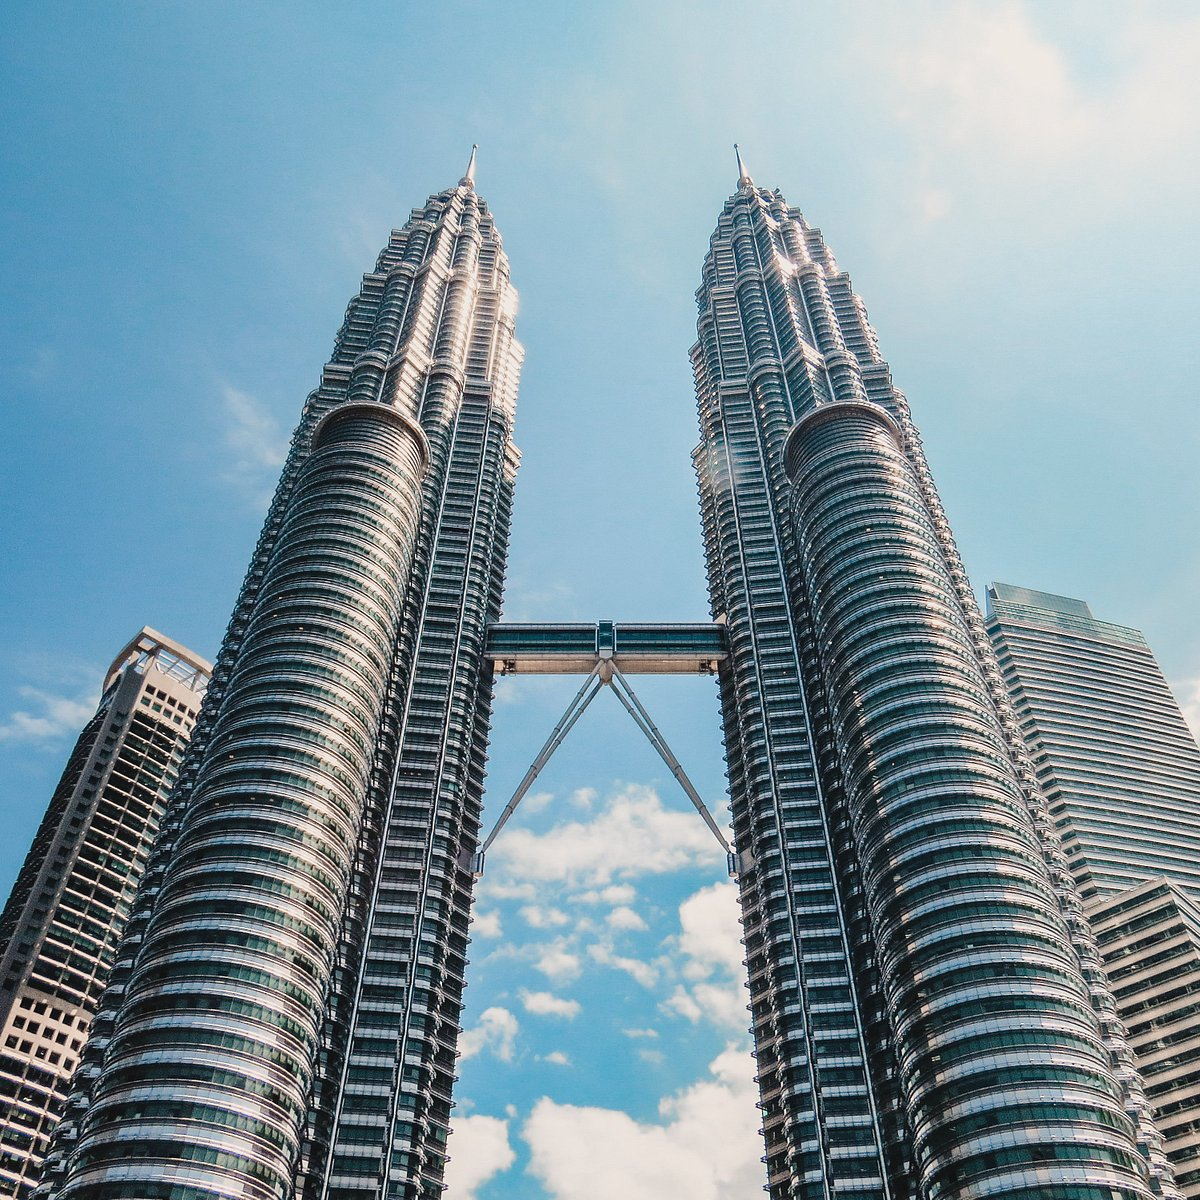How do the design aspects of Petronas Twin Towers reflect the Islamic architectural influences? The design of the Petronas Twin Towers incorporates several elements characteristic of Islamic architecture. The towers' floor plan is based on an eight-pointed star, a common motif in Islamic design, which can be observed not only at its base but also throughout its structure. The towers' spires, resembling minarets, and the intricate detailing in the facade further echo Islamic artistic traditions, seamlessly merging them with modern architectural techniques. 